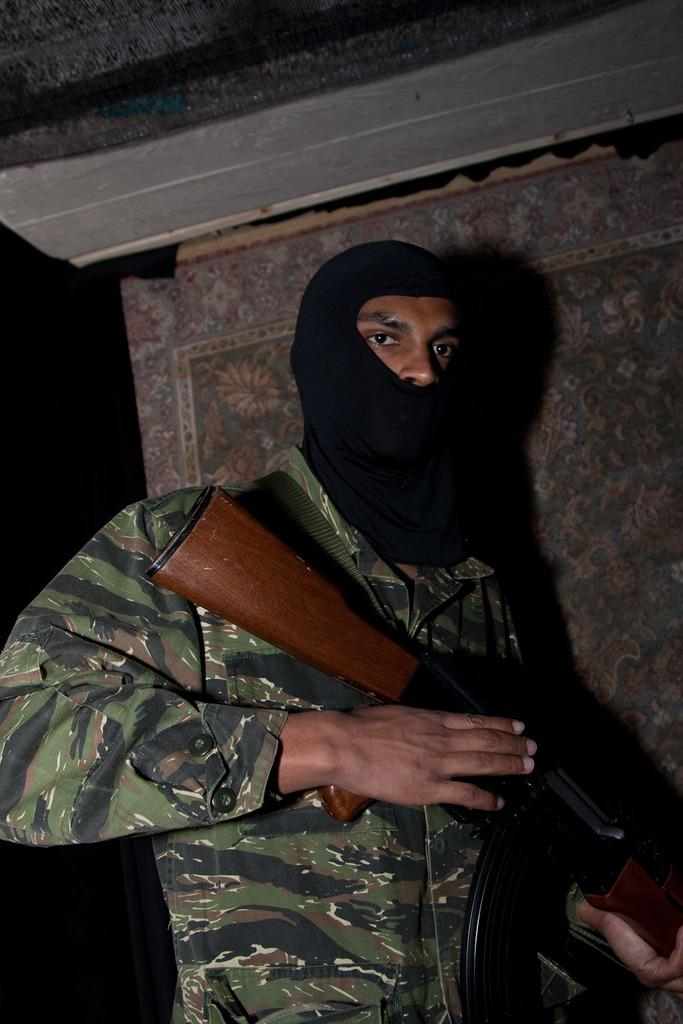What is the main subject of the image? There is a person standing in the image. What is the person holding in the image? The person is holding a rifle. What can be seen in the background of the image? There is a wall poster in the background of the image. What type of sign is the person holding in the image? There is no sign present in the image; the person is holding a rifle. How many screws can be seen on the wall poster in the image? There is no information about screws on the wall poster in the image, as we only know that there is a wall poster present. 